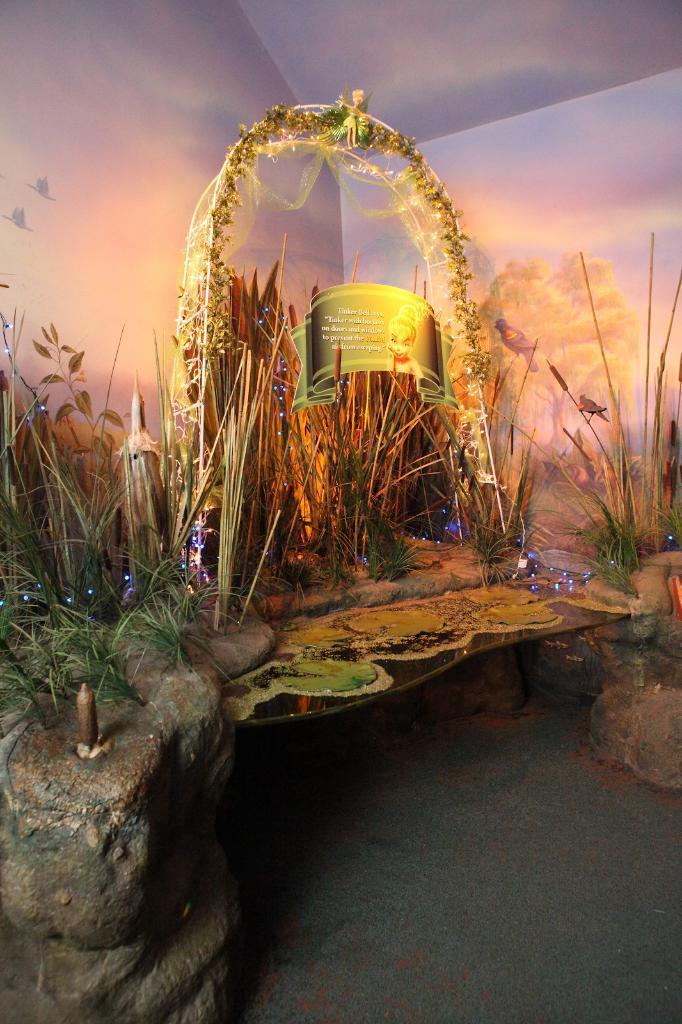Please provide a concise description of this image. As we can see in the image there is water, white color wall, plants, banner and lights. 